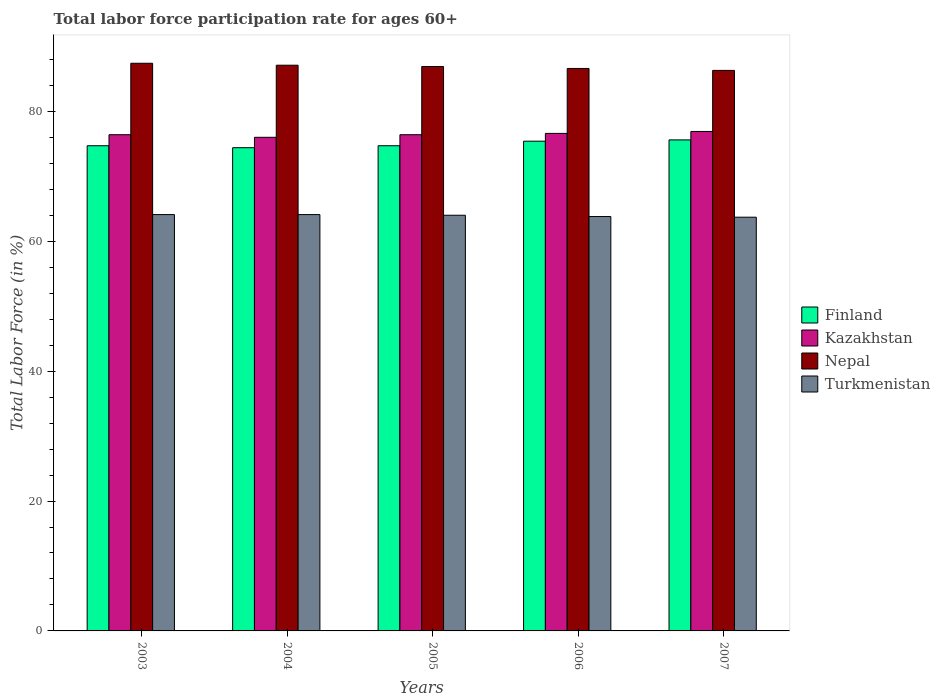How many different coloured bars are there?
Make the answer very short. 4. Are the number of bars per tick equal to the number of legend labels?
Your response must be concise. Yes. How many bars are there on the 5th tick from the left?
Ensure brevity in your answer.  4. How many bars are there on the 4th tick from the right?
Provide a short and direct response. 4. What is the label of the 2nd group of bars from the left?
Give a very brief answer. 2004. In how many cases, is the number of bars for a given year not equal to the number of legend labels?
Your answer should be compact. 0. What is the labor force participation rate in Kazakhstan in 2003?
Provide a short and direct response. 76.4. Across all years, what is the maximum labor force participation rate in Turkmenistan?
Keep it short and to the point. 64.1. Across all years, what is the minimum labor force participation rate in Turkmenistan?
Give a very brief answer. 63.7. In which year was the labor force participation rate in Finland maximum?
Ensure brevity in your answer.  2007. In which year was the labor force participation rate in Kazakhstan minimum?
Make the answer very short. 2004. What is the total labor force participation rate in Nepal in the graph?
Provide a short and direct response. 434.3. What is the difference between the labor force participation rate in Turkmenistan in 2005 and that in 2007?
Ensure brevity in your answer.  0.3. What is the difference between the labor force participation rate in Kazakhstan in 2005 and the labor force participation rate in Turkmenistan in 2003?
Offer a very short reply. 12.3. What is the average labor force participation rate in Turkmenistan per year?
Give a very brief answer. 63.94. In the year 2005, what is the difference between the labor force participation rate in Turkmenistan and labor force participation rate in Finland?
Your answer should be very brief. -10.7. In how many years, is the labor force participation rate in Finland greater than 28 %?
Your answer should be very brief. 5. What is the ratio of the labor force participation rate in Kazakhstan in 2003 to that in 2006?
Offer a terse response. 1. Is the labor force participation rate in Turkmenistan in 2006 less than that in 2007?
Provide a short and direct response. No. What is the difference between the highest and the second highest labor force participation rate in Nepal?
Provide a short and direct response. 0.3. What is the difference between the highest and the lowest labor force participation rate in Finland?
Provide a succinct answer. 1.2. In how many years, is the labor force participation rate in Kazakhstan greater than the average labor force participation rate in Kazakhstan taken over all years?
Your answer should be compact. 2. Is it the case that in every year, the sum of the labor force participation rate in Turkmenistan and labor force participation rate in Nepal is greater than the sum of labor force participation rate in Finland and labor force participation rate in Kazakhstan?
Provide a short and direct response. No. What does the 2nd bar from the left in 2003 represents?
Provide a succinct answer. Kazakhstan. Is it the case that in every year, the sum of the labor force participation rate in Finland and labor force participation rate in Nepal is greater than the labor force participation rate in Turkmenistan?
Provide a short and direct response. Yes. Are all the bars in the graph horizontal?
Provide a succinct answer. No. What is the difference between two consecutive major ticks on the Y-axis?
Ensure brevity in your answer.  20. Are the values on the major ticks of Y-axis written in scientific E-notation?
Keep it short and to the point. No. Does the graph contain any zero values?
Make the answer very short. No. What is the title of the graph?
Your response must be concise. Total labor force participation rate for ages 60+. Does "Eritrea" appear as one of the legend labels in the graph?
Your answer should be compact. No. What is the label or title of the X-axis?
Your response must be concise. Years. What is the label or title of the Y-axis?
Offer a terse response. Total Labor Force (in %). What is the Total Labor Force (in %) in Finland in 2003?
Offer a terse response. 74.7. What is the Total Labor Force (in %) in Kazakhstan in 2003?
Keep it short and to the point. 76.4. What is the Total Labor Force (in %) in Nepal in 2003?
Offer a terse response. 87.4. What is the Total Labor Force (in %) in Turkmenistan in 2003?
Provide a succinct answer. 64.1. What is the Total Labor Force (in %) of Finland in 2004?
Your answer should be very brief. 74.4. What is the Total Labor Force (in %) of Kazakhstan in 2004?
Keep it short and to the point. 76. What is the Total Labor Force (in %) in Nepal in 2004?
Offer a terse response. 87.1. What is the Total Labor Force (in %) in Turkmenistan in 2004?
Provide a short and direct response. 64.1. What is the Total Labor Force (in %) in Finland in 2005?
Keep it short and to the point. 74.7. What is the Total Labor Force (in %) of Kazakhstan in 2005?
Ensure brevity in your answer.  76.4. What is the Total Labor Force (in %) in Nepal in 2005?
Offer a terse response. 86.9. What is the Total Labor Force (in %) of Turkmenistan in 2005?
Your answer should be compact. 64. What is the Total Labor Force (in %) in Finland in 2006?
Ensure brevity in your answer.  75.4. What is the Total Labor Force (in %) in Kazakhstan in 2006?
Keep it short and to the point. 76.6. What is the Total Labor Force (in %) in Nepal in 2006?
Provide a succinct answer. 86.6. What is the Total Labor Force (in %) of Turkmenistan in 2006?
Your response must be concise. 63.8. What is the Total Labor Force (in %) of Finland in 2007?
Offer a terse response. 75.6. What is the Total Labor Force (in %) of Kazakhstan in 2007?
Ensure brevity in your answer.  76.9. What is the Total Labor Force (in %) in Nepal in 2007?
Ensure brevity in your answer.  86.3. What is the Total Labor Force (in %) in Turkmenistan in 2007?
Offer a terse response. 63.7. Across all years, what is the maximum Total Labor Force (in %) of Finland?
Make the answer very short. 75.6. Across all years, what is the maximum Total Labor Force (in %) in Kazakhstan?
Give a very brief answer. 76.9. Across all years, what is the maximum Total Labor Force (in %) of Nepal?
Offer a terse response. 87.4. Across all years, what is the maximum Total Labor Force (in %) of Turkmenistan?
Provide a short and direct response. 64.1. Across all years, what is the minimum Total Labor Force (in %) of Finland?
Your response must be concise. 74.4. Across all years, what is the minimum Total Labor Force (in %) in Kazakhstan?
Provide a short and direct response. 76. Across all years, what is the minimum Total Labor Force (in %) of Nepal?
Your response must be concise. 86.3. Across all years, what is the minimum Total Labor Force (in %) in Turkmenistan?
Ensure brevity in your answer.  63.7. What is the total Total Labor Force (in %) in Finland in the graph?
Ensure brevity in your answer.  374.8. What is the total Total Labor Force (in %) of Kazakhstan in the graph?
Make the answer very short. 382.3. What is the total Total Labor Force (in %) in Nepal in the graph?
Ensure brevity in your answer.  434.3. What is the total Total Labor Force (in %) of Turkmenistan in the graph?
Your answer should be compact. 319.7. What is the difference between the Total Labor Force (in %) of Finland in 2003 and that in 2004?
Provide a short and direct response. 0.3. What is the difference between the Total Labor Force (in %) of Kazakhstan in 2003 and that in 2004?
Provide a short and direct response. 0.4. What is the difference between the Total Labor Force (in %) of Finland in 2003 and that in 2005?
Offer a terse response. 0. What is the difference between the Total Labor Force (in %) of Turkmenistan in 2003 and that in 2005?
Provide a succinct answer. 0.1. What is the difference between the Total Labor Force (in %) in Finland in 2003 and that in 2006?
Offer a very short reply. -0.7. What is the difference between the Total Labor Force (in %) in Nepal in 2003 and that in 2006?
Ensure brevity in your answer.  0.8. What is the difference between the Total Labor Force (in %) in Turkmenistan in 2003 and that in 2006?
Your answer should be compact. 0.3. What is the difference between the Total Labor Force (in %) of Finland in 2003 and that in 2007?
Give a very brief answer. -0.9. What is the difference between the Total Labor Force (in %) of Finland in 2004 and that in 2005?
Your answer should be compact. -0.3. What is the difference between the Total Labor Force (in %) of Nepal in 2004 and that in 2005?
Your response must be concise. 0.2. What is the difference between the Total Labor Force (in %) of Turkmenistan in 2004 and that in 2005?
Your response must be concise. 0.1. What is the difference between the Total Labor Force (in %) of Turkmenistan in 2004 and that in 2006?
Provide a succinct answer. 0.3. What is the difference between the Total Labor Force (in %) of Finland in 2004 and that in 2007?
Your answer should be compact. -1.2. What is the difference between the Total Labor Force (in %) of Turkmenistan in 2004 and that in 2007?
Keep it short and to the point. 0.4. What is the difference between the Total Labor Force (in %) of Kazakhstan in 2005 and that in 2006?
Your response must be concise. -0.2. What is the difference between the Total Labor Force (in %) in Turkmenistan in 2005 and that in 2006?
Offer a very short reply. 0.2. What is the difference between the Total Labor Force (in %) of Nepal in 2005 and that in 2007?
Your answer should be compact. 0.6. What is the difference between the Total Labor Force (in %) in Turkmenistan in 2005 and that in 2007?
Keep it short and to the point. 0.3. What is the difference between the Total Labor Force (in %) of Finland in 2006 and that in 2007?
Offer a very short reply. -0.2. What is the difference between the Total Labor Force (in %) in Kazakhstan in 2006 and that in 2007?
Offer a terse response. -0.3. What is the difference between the Total Labor Force (in %) of Turkmenistan in 2006 and that in 2007?
Make the answer very short. 0.1. What is the difference between the Total Labor Force (in %) of Finland in 2003 and the Total Labor Force (in %) of Turkmenistan in 2004?
Provide a succinct answer. 10.6. What is the difference between the Total Labor Force (in %) of Kazakhstan in 2003 and the Total Labor Force (in %) of Nepal in 2004?
Provide a short and direct response. -10.7. What is the difference between the Total Labor Force (in %) of Nepal in 2003 and the Total Labor Force (in %) of Turkmenistan in 2004?
Your answer should be compact. 23.3. What is the difference between the Total Labor Force (in %) in Finland in 2003 and the Total Labor Force (in %) in Kazakhstan in 2005?
Provide a succinct answer. -1.7. What is the difference between the Total Labor Force (in %) in Finland in 2003 and the Total Labor Force (in %) in Nepal in 2005?
Make the answer very short. -12.2. What is the difference between the Total Labor Force (in %) in Finland in 2003 and the Total Labor Force (in %) in Turkmenistan in 2005?
Offer a very short reply. 10.7. What is the difference between the Total Labor Force (in %) in Nepal in 2003 and the Total Labor Force (in %) in Turkmenistan in 2005?
Offer a terse response. 23.4. What is the difference between the Total Labor Force (in %) in Finland in 2003 and the Total Labor Force (in %) in Kazakhstan in 2006?
Your response must be concise. -1.9. What is the difference between the Total Labor Force (in %) in Finland in 2003 and the Total Labor Force (in %) in Nepal in 2006?
Offer a terse response. -11.9. What is the difference between the Total Labor Force (in %) of Kazakhstan in 2003 and the Total Labor Force (in %) of Turkmenistan in 2006?
Provide a short and direct response. 12.6. What is the difference between the Total Labor Force (in %) in Nepal in 2003 and the Total Labor Force (in %) in Turkmenistan in 2006?
Give a very brief answer. 23.6. What is the difference between the Total Labor Force (in %) in Finland in 2003 and the Total Labor Force (in %) in Kazakhstan in 2007?
Provide a short and direct response. -2.2. What is the difference between the Total Labor Force (in %) of Kazakhstan in 2003 and the Total Labor Force (in %) of Turkmenistan in 2007?
Offer a very short reply. 12.7. What is the difference between the Total Labor Force (in %) in Nepal in 2003 and the Total Labor Force (in %) in Turkmenistan in 2007?
Your answer should be compact. 23.7. What is the difference between the Total Labor Force (in %) in Finland in 2004 and the Total Labor Force (in %) in Nepal in 2005?
Provide a succinct answer. -12.5. What is the difference between the Total Labor Force (in %) in Kazakhstan in 2004 and the Total Labor Force (in %) in Nepal in 2005?
Keep it short and to the point. -10.9. What is the difference between the Total Labor Force (in %) in Nepal in 2004 and the Total Labor Force (in %) in Turkmenistan in 2005?
Make the answer very short. 23.1. What is the difference between the Total Labor Force (in %) of Finland in 2004 and the Total Labor Force (in %) of Nepal in 2006?
Offer a very short reply. -12.2. What is the difference between the Total Labor Force (in %) of Finland in 2004 and the Total Labor Force (in %) of Turkmenistan in 2006?
Offer a terse response. 10.6. What is the difference between the Total Labor Force (in %) of Kazakhstan in 2004 and the Total Labor Force (in %) of Nepal in 2006?
Your answer should be very brief. -10.6. What is the difference between the Total Labor Force (in %) of Nepal in 2004 and the Total Labor Force (in %) of Turkmenistan in 2006?
Your answer should be compact. 23.3. What is the difference between the Total Labor Force (in %) of Finland in 2004 and the Total Labor Force (in %) of Kazakhstan in 2007?
Make the answer very short. -2.5. What is the difference between the Total Labor Force (in %) in Finland in 2004 and the Total Labor Force (in %) in Nepal in 2007?
Your response must be concise. -11.9. What is the difference between the Total Labor Force (in %) in Finland in 2004 and the Total Labor Force (in %) in Turkmenistan in 2007?
Make the answer very short. 10.7. What is the difference between the Total Labor Force (in %) in Nepal in 2004 and the Total Labor Force (in %) in Turkmenistan in 2007?
Give a very brief answer. 23.4. What is the difference between the Total Labor Force (in %) in Finland in 2005 and the Total Labor Force (in %) in Kazakhstan in 2006?
Ensure brevity in your answer.  -1.9. What is the difference between the Total Labor Force (in %) in Finland in 2005 and the Total Labor Force (in %) in Nepal in 2006?
Your response must be concise. -11.9. What is the difference between the Total Labor Force (in %) of Finland in 2005 and the Total Labor Force (in %) of Turkmenistan in 2006?
Your response must be concise. 10.9. What is the difference between the Total Labor Force (in %) of Kazakhstan in 2005 and the Total Labor Force (in %) of Nepal in 2006?
Give a very brief answer. -10.2. What is the difference between the Total Labor Force (in %) in Nepal in 2005 and the Total Labor Force (in %) in Turkmenistan in 2006?
Offer a very short reply. 23.1. What is the difference between the Total Labor Force (in %) of Finland in 2005 and the Total Labor Force (in %) of Kazakhstan in 2007?
Offer a terse response. -2.2. What is the difference between the Total Labor Force (in %) in Finland in 2005 and the Total Labor Force (in %) in Nepal in 2007?
Give a very brief answer. -11.6. What is the difference between the Total Labor Force (in %) in Kazakhstan in 2005 and the Total Labor Force (in %) in Nepal in 2007?
Your response must be concise. -9.9. What is the difference between the Total Labor Force (in %) in Kazakhstan in 2005 and the Total Labor Force (in %) in Turkmenistan in 2007?
Provide a succinct answer. 12.7. What is the difference between the Total Labor Force (in %) in Nepal in 2005 and the Total Labor Force (in %) in Turkmenistan in 2007?
Your response must be concise. 23.2. What is the difference between the Total Labor Force (in %) in Finland in 2006 and the Total Labor Force (in %) in Kazakhstan in 2007?
Offer a terse response. -1.5. What is the difference between the Total Labor Force (in %) in Finland in 2006 and the Total Labor Force (in %) in Turkmenistan in 2007?
Ensure brevity in your answer.  11.7. What is the difference between the Total Labor Force (in %) in Kazakhstan in 2006 and the Total Labor Force (in %) in Nepal in 2007?
Offer a terse response. -9.7. What is the difference between the Total Labor Force (in %) of Nepal in 2006 and the Total Labor Force (in %) of Turkmenistan in 2007?
Your response must be concise. 22.9. What is the average Total Labor Force (in %) of Finland per year?
Give a very brief answer. 74.96. What is the average Total Labor Force (in %) in Kazakhstan per year?
Keep it short and to the point. 76.46. What is the average Total Labor Force (in %) in Nepal per year?
Provide a short and direct response. 86.86. What is the average Total Labor Force (in %) of Turkmenistan per year?
Offer a terse response. 63.94. In the year 2003, what is the difference between the Total Labor Force (in %) in Finland and Total Labor Force (in %) in Nepal?
Give a very brief answer. -12.7. In the year 2003, what is the difference between the Total Labor Force (in %) in Kazakhstan and Total Labor Force (in %) in Nepal?
Ensure brevity in your answer.  -11. In the year 2003, what is the difference between the Total Labor Force (in %) in Nepal and Total Labor Force (in %) in Turkmenistan?
Provide a short and direct response. 23.3. In the year 2004, what is the difference between the Total Labor Force (in %) of Finland and Total Labor Force (in %) of Turkmenistan?
Offer a terse response. 10.3. In the year 2004, what is the difference between the Total Labor Force (in %) of Kazakhstan and Total Labor Force (in %) of Nepal?
Provide a succinct answer. -11.1. In the year 2004, what is the difference between the Total Labor Force (in %) of Nepal and Total Labor Force (in %) of Turkmenistan?
Ensure brevity in your answer.  23. In the year 2005, what is the difference between the Total Labor Force (in %) of Finland and Total Labor Force (in %) of Nepal?
Provide a short and direct response. -12.2. In the year 2005, what is the difference between the Total Labor Force (in %) of Kazakhstan and Total Labor Force (in %) of Turkmenistan?
Make the answer very short. 12.4. In the year 2005, what is the difference between the Total Labor Force (in %) in Nepal and Total Labor Force (in %) in Turkmenistan?
Your answer should be very brief. 22.9. In the year 2006, what is the difference between the Total Labor Force (in %) of Finland and Total Labor Force (in %) of Kazakhstan?
Ensure brevity in your answer.  -1.2. In the year 2006, what is the difference between the Total Labor Force (in %) in Finland and Total Labor Force (in %) in Turkmenistan?
Your answer should be very brief. 11.6. In the year 2006, what is the difference between the Total Labor Force (in %) of Kazakhstan and Total Labor Force (in %) of Turkmenistan?
Ensure brevity in your answer.  12.8. In the year 2006, what is the difference between the Total Labor Force (in %) in Nepal and Total Labor Force (in %) in Turkmenistan?
Give a very brief answer. 22.8. In the year 2007, what is the difference between the Total Labor Force (in %) of Finland and Total Labor Force (in %) of Nepal?
Your response must be concise. -10.7. In the year 2007, what is the difference between the Total Labor Force (in %) of Kazakhstan and Total Labor Force (in %) of Nepal?
Keep it short and to the point. -9.4. In the year 2007, what is the difference between the Total Labor Force (in %) in Kazakhstan and Total Labor Force (in %) in Turkmenistan?
Provide a succinct answer. 13.2. In the year 2007, what is the difference between the Total Labor Force (in %) in Nepal and Total Labor Force (in %) in Turkmenistan?
Offer a very short reply. 22.6. What is the ratio of the Total Labor Force (in %) of Nepal in 2003 to that in 2004?
Ensure brevity in your answer.  1. What is the ratio of the Total Labor Force (in %) of Turkmenistan in 2003 to that in 2004?
Your response must be concise. 1. What is the ratio of the Total Labor Force (in %) in Finland in 2003 to that in 2005?
Make the answer very short. 1. What is the ratio of the Total Labor Force (in %) in Kazakhstan in 2003 to that in 2005?
Give a very brief answer. 1. What is the ratio of the Total Labor Force (in %) of Turkmenistan in 2003 to that in 2005?
Give a very brief answer. 1. What is the ratio of the Total Labor Force (in %) in Finland in 2003 to that in 2006?
Give a very brief answer. 0.99. What is the ratio of the Total Labor Force (in %) of Nepal in 2003 to that in 2006?
Your answer should be compact. 1.01. What is the ratio of the Total Labor Force (in %) in Finland in 2003 to that in 2007?
Give a very brief answer. 0.99. What is the ratio of the Total Labor Force (in %) of Nepal in 2003 to that in 2007?
Offer a terse response. 1.01. What is the ratio of the Total Labor Force (in %) in Turkmenistan in 2003 to that in 2007?
Ensure brevity in your answer.  1.01. What is the ratio of the Total Labor Force (in %) of Turkmenistan in 2004 to that in 2005?
Your answer should be compact. 1. What is the ratio of the Total Labor Force (in %) in Finland in 2004 to that in 2006?
Give a very brief answer. 0.99. What is the ratio of the Total Labor Force (in %) of Nepal in 2004 to that in 2006?
Make the answer very short. 1.01. What is the ratio of the Total Labor Force (in %) of Finland in 2004 to that in 2007?
Your answer should be very brief. 0.98. What is the ratio of the Total Labor Force (in %) of Kazakhstan in 2004 to that in 2007?
Give a very brief answer. 0.99. What is the ratio of the Total Labor Force (in %) in Nepal in 2004 to that in 2007?
Give a very brief answer. 1.01. What is the ratio of the Total Labor Force (in %) in Turkmenistan in 2004 to that in 2007?
Offer a very short reply. 1.01. What is the ratio of the Total Labor Force (in %) of Nepal in 2005 to that in 2007?
Offer a terse response. 1.01. What is the ratio of the Total Labor Force (in %) in Turkmenistan in 2005 to that in 2007?
Ensure brevity in your answer.  1. What is the difference between the highest and the second highest Total Labor Force (in %) in Finland?
Provide a short and direct response. 0.2. What is the difference between the highest and the second highest Total Labor Force (in %) in Kazakhstan?
Give a very brief answer. 0.3. What is the difference between the highest and the second highest Total Labor Force (in %) in Nepal?
Make the answer very short. 0.3. What is the difference between the highest and the second highest Total Labor Force (in %) of Turkmenistan?
Offer a very short reply. 0. What is the difference between the highest and the lowest Total Labor Force (in %) in Finland?
Your answer should be very brief. 1.2. 